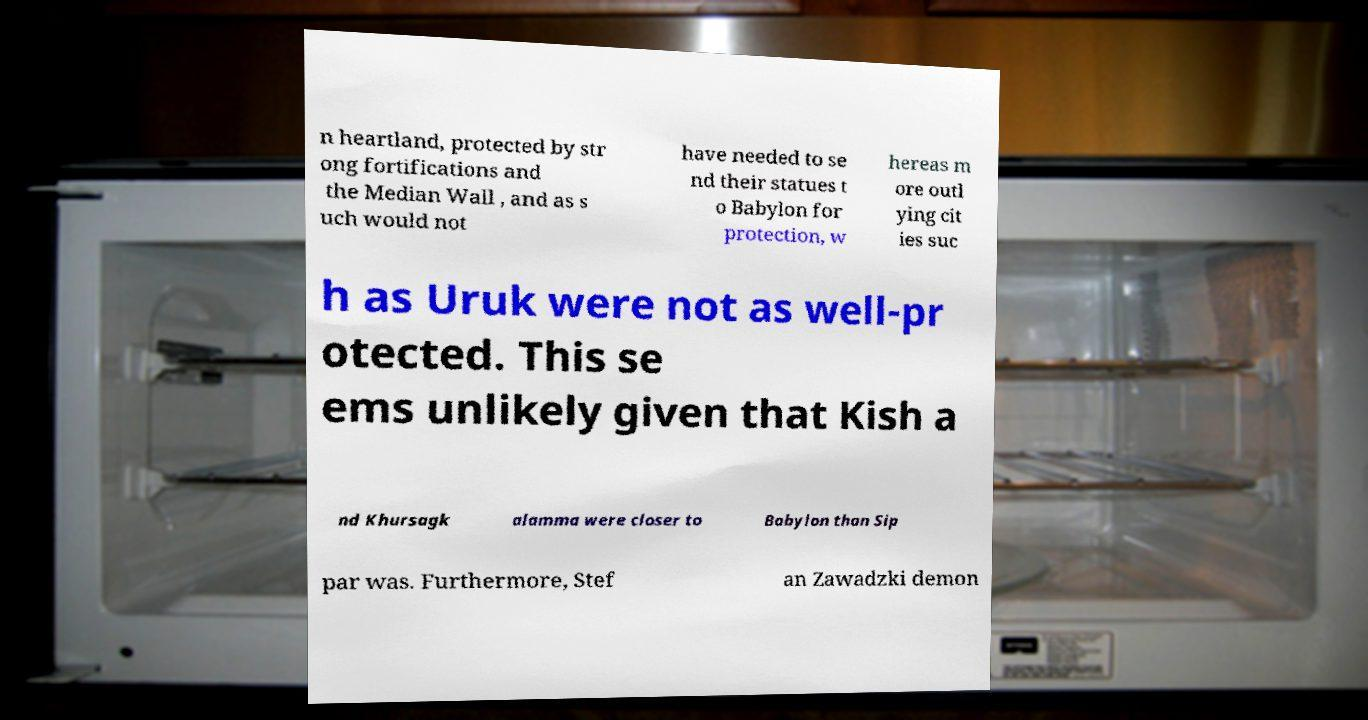Could you assist in decoding the text presented in this image and type it out clearly? n heartland, protected by str ong fortifications and the Median Wall , and as s uch would not have needed to se nd their statues t o Babylon for protection, w hereas m ore outl ying cit ies suc h as Uruk were not as well-pr otected. This se ems unlikely given that Kish a nd Khursagk alamma were closer to Babylon than Sip par was. Furthermore, Stef an Zawadzki demon 